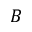<formula> <loc_0><loc_0><loc_500><loc_500>B</formula> 